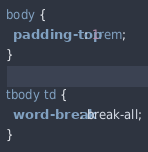Convert code to text. <code><loc_0><loc_0><loc_500><loc_500><_CSS_>body {
  padding-top: 1rem;
}

tbody td {
  word-break: break-all;
}
</code> 